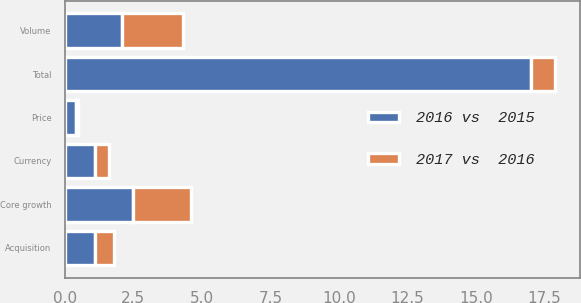<chart> <loc_0><loc_0><loc_500><loc_500><stacked_bar_chart><ecel><fcel>Volume<fcel>Price<fcel>Core growth<fcel>Acquisition<fcel>Currency<fcel>Total<nl><fcel>2017 vs  2016<fcel>2.2<fcel>0.1<fcel>2.1<fcel>0.7<fcel>0.5<fcel>0.9<nl><fcel>2016 vs  2015<fcel>2.1<fcel>0.4<fcel>2.5<fcel>1.1<fcel>1.1<fcel>17<nl></chart> 